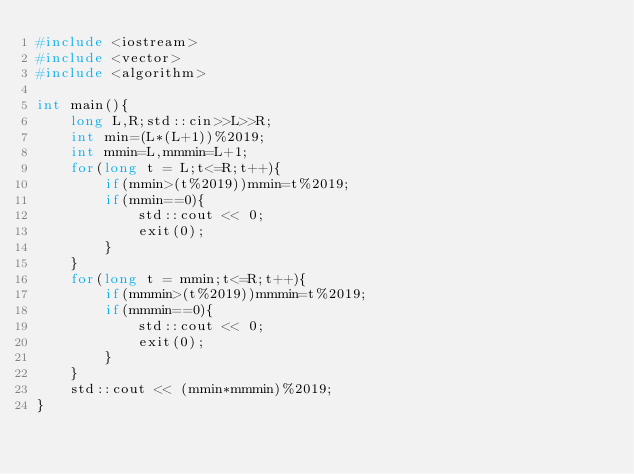<code> <loc_0><loc_0><loc_500><loc_500><_C++_>#include <iostream>
#include <vector>
#include <algorithm>

int main(){
    long L,R;std::cin>>L>>R;
    int min=(L*(L+1))%2019;
    int mmin=L,mmmin=L+1;
    for(long t = L;t<=R;t++){
        if(mmin>(t%2019))mmin=t%2019;
        if(mmin==0){
            std::cout << 0;
            exit(0);
        }
    }
    for(long t = mmin;t<=R;t++){
        if(mmmin>(t%2019))mmmin=t%2019;
        if(mmmin==0){
            std::cout << 0;
            exit(0);
        }
    }
    std::cout << (mmin*mmmin)%2019;
}</code> 